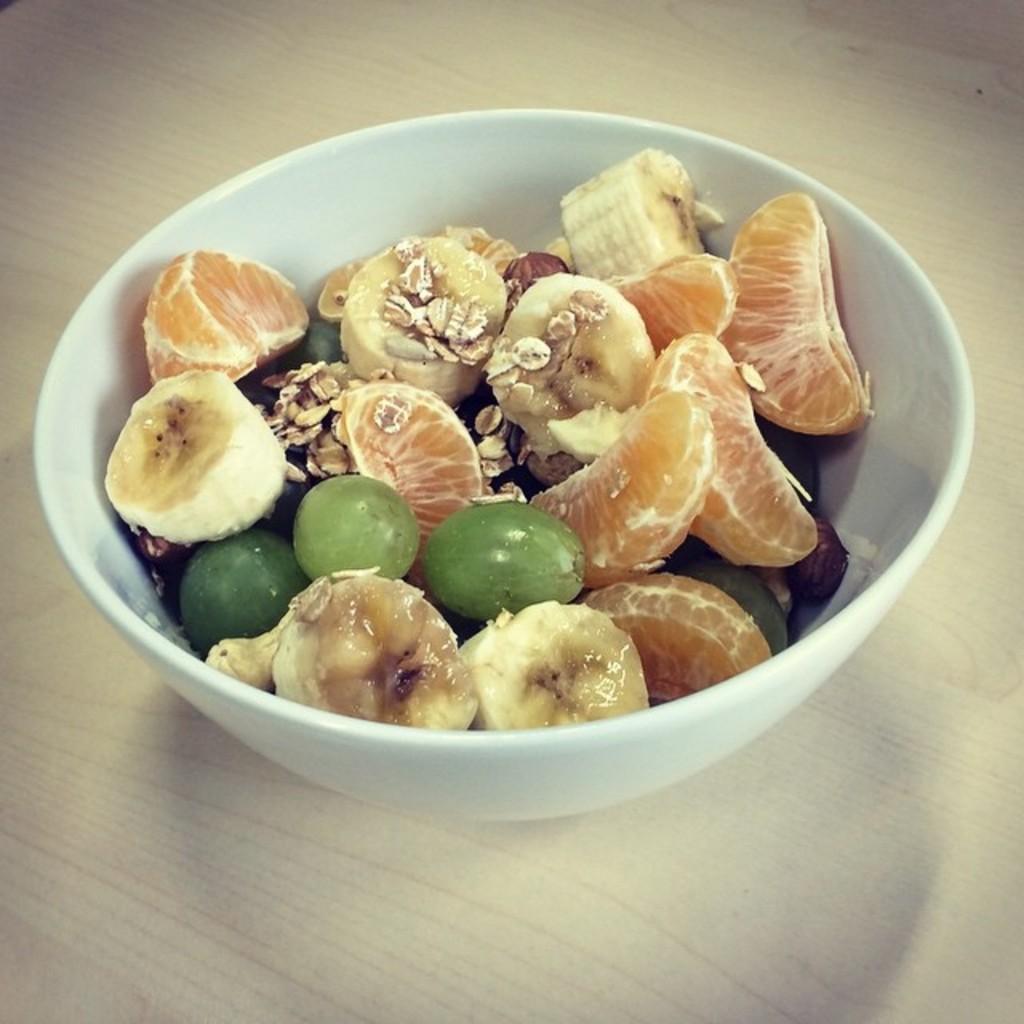Can you describe this image briefly? In this picture I can observe some fruits in the white color bowl. I can observe oranges, bananas and grapes in the bowl. 